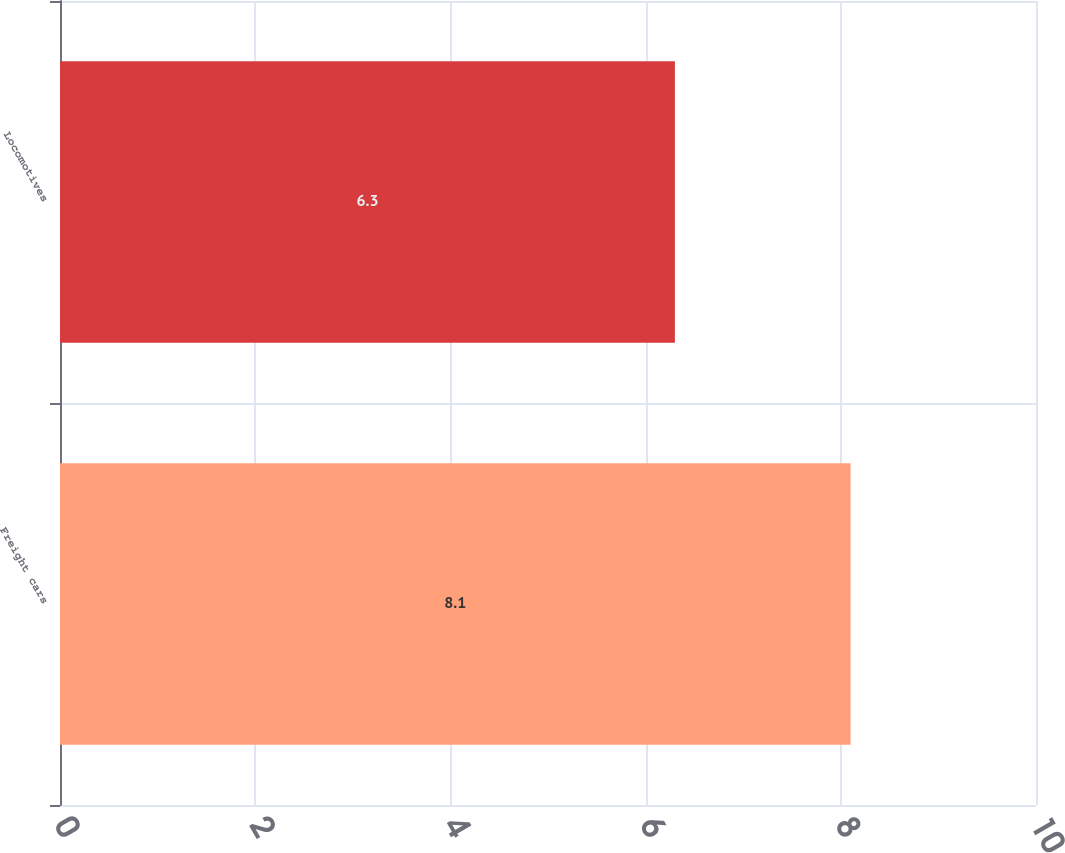Convert chart. <chart><loc_0><loc_0><loc_500><loc_500><bar_chart><fcel>Freight cars<fcel>Locomotives<nl><fcel>8.1<fcel>6.3<nl></chart> 